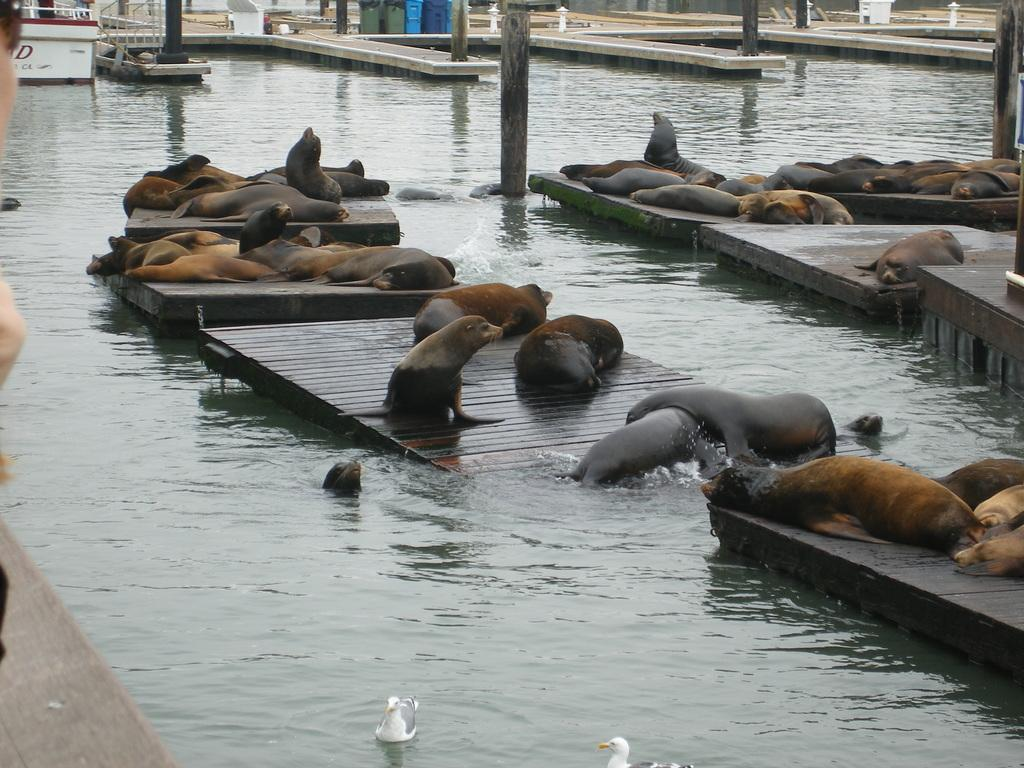What is the primary element visible in the image? There is a water surface in the image. What is placed on the water surface? There are wooden planks on the water surface. What type of animals can be seen on the wooden planks? There are many seals on the wooden planks. What type of stocking is being used to protect the produce in the image? There is no stocking or produce present in the image; it features a water surface with wooden planks and seals. 